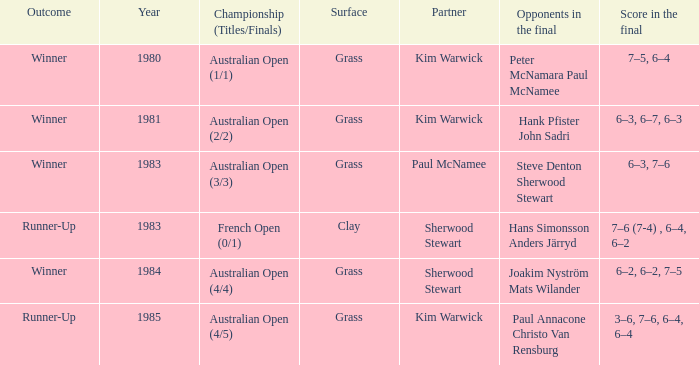How many different partners were played with during French Open (0/1)? 1.0. 